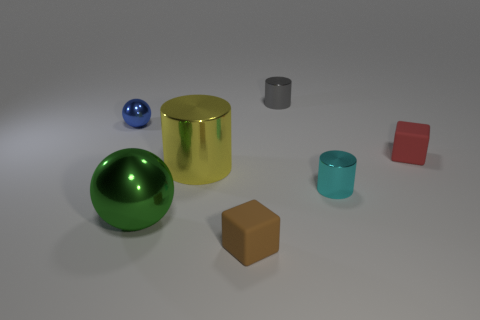Subtract all gray shiny cylinders. How many cylinders are left? 2 Add 1 large objects. How many objects exist? 8 Subtract all brown cubes. How many cubes are left? 1 Subtract all balls. How many objects are left? 5 Subtract 1 gray cylinders. How many objects are left? 6 Subtract 1 balls. How many balls are left? 1 Subtract all green cylinders. Subtract all gray balls. How many cylinders are left? 3 Subtract all gray blocks. How many blue spheres are left? 1 Subtract all purple rubber cubes. Subtract all tiny balls. How many objects are left? 6 Add 2 big shiny cylinders. How many big shiny cylinders are left? 3 